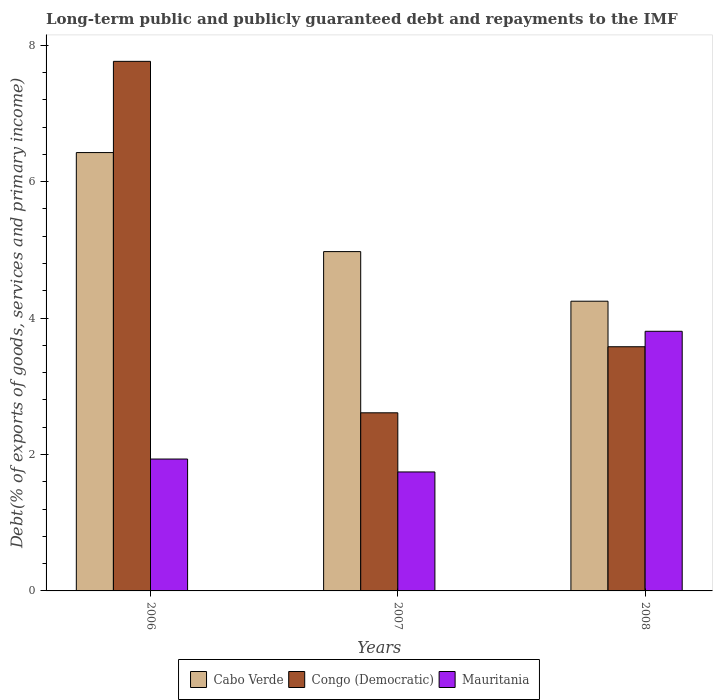How many different coloured bars are there?
Provide a short and direct response. 3. What is the debt and repayments in Congo (Democratic) in 2006?
Make the answer very short. 7.76. Across all years, what is the maximum debt and repayments in Mauritania?
Keep it short and to the point. 3.81. Across all years, what is the minimum debt and repayments in Cabo Verde?
Provide a short and direct response. 4.25. In which year was the debt and repayments in Congo (Democratic) maximum?
Provide a short and direct response. 2006. In which year was the debt and repayments in Cabo Verde minimum?
Keep it short and to the point. 2008. What is the total debt and repayments in Mauritania in the graph?
Ensure brevity in your answer.  7.48. What is the difference between the debt and repayments in Congo (Democratic) in 2006 and that in 2008?
Offer a very short reply. 4.18. What is the difference between the debt and repayments in Mauritania in 2007 and the debt and repayments in Congo (Democratic) in 2006?
Your answer should be compact. -6.02. What is the average debt and repayments in Mauritania per year?
Ensure brevity in your answer.  2.49. In the year 2007, what is the difference between the debt and repayments in Cabo Verde and debt and repayments in Mauritania?
Give a very brief answer. 3.23. What is the ratio of the debt and repayments in Mauritania in 2006 to that in 2008?
Keep it short and to the point. 0.51. Is the difference between the debt and repayments in Cabo Verde in 2006 and 2008 greater than the difference between the debt and repayments in Mauritania in 2006 and 2008?
Your answer should be very brief. Yes. What is the difference between the highest and the second highest debt and repayments in Cabo Verde?
Provide a short and direct response. 1.45. What is the difference between the highest and the lowest debt and repayments in Congo (Democratic)?
Your answer should be compact. 5.15. In how many years, is the debt and repayments in Cabo Verde greater than the average debt and repayments in Cabo Verde taken over all years?
Your response must be concise. 1. What does the 3rd bar from the left in 2006 represents?
Offer a very short reply. Mauritania. What does the 1st bar from the right in 2007 represents?
Make the answer very short. Mauritania. How many years are there in the graph?
Offer a very short reply. 3. What is the difference between two consecutive major ticks on the Y-axis?
Keep it short and to the point. 2. Does the graph contain any zero values?
Offer a very short reply. No. Where does the legend appear in the graph?
Offer a very short reply. Bottom center. How many legend labels are there?
Your answer should be compact. 3. How are the legend labels stacked?
Provide a short and direct response. Horizontal. What is the title of the graph?
Provide a short and direct response. Long-term public and publicly guaranteed debt and repayments to the IMF. What is the label or title of the X-axis?
Your answer should be compact. Years. What is the label or title of the Y-axis?
Provide a succinct answer. Debt(% of exports of goods, services and primary income). What is the Debt(% of exports of goods, services and primary income) of Cabo Verde in 2006?
Provide a short and direct response. 6.43. What is the Debt(% of exports of goods, services and primary income) in Congo (Democratic) in 2006?
Provide a succinct answer. 7.76. What is the Debt(% of exports of goods, services and primary income) of Mauritania in 2006?
Your answer should be very brief. 1.93. What is the Debt(% of exports of goods, services and primary income) of Cabo Verde in 2007?
Your answer should be compact. 4.97. What is the Debt(% of exports of goods, services and primary income) of Congo (Democratic) in 2007?
Offer a very short reply. 2.61. What is the Debt(% of exports of goods, services and primary income) of Mauritania in 2007?
Ensure brevity in your answer.  1.74. What is the Debt(% of exports of goods, services and primary income) in Cabo Verde in 2008?
Offer a terse response. 4.25. What is the Debt(% of exports of goods, services and primary income) of Congo (Democratic) in 2008?
Offer a terse response. 3.58. What is the Debt(% of exports of goods, services and primary income) of Mauritania in 2008?
Provide a short and direct response. 3.81. Across all years, what is the maximum Debt(% of exports of goods, services and primary income) in Cabo Verde?
Keep it short and to the point. 6.43. Across all years, what is the maximum Debt(% of exports of goods, services and primary income) of Congo (Democratic)?
Make the answer very short. 7.76. Across all years, what is the maximum Debt(% of exports of goods, services and primary income) of Mauritania?
Offer a very short reply. 3.81. Across all years, what is the minimum Debt(% of exports of goods, services and primary income) of Cabo Verde?
Give a very brief answer. 4.25. Across all years, what is the minimum Debt(% of exports of goods, services and primary income) of Congo (Democratic)?
Provide a short and direct response. 2.61. Across all years, what is the minimum Debt(% of exports of goods, services and primary income) of Mauritania?
Ensure brevity in your answer.  1.74. What is the total Debt(% of exports of goods, services and primary income) in Cabo Verde in the graph?
Your response must be concise. 15.65. What is the total Debt(% of exports of goods, services and primary income) in Congo (Democratic) in the graph?
Provide a succinct answer. 13.96. What is the total Debt(% of exports of goods, services and primary income) in Mauritania in the graph?
Keep it short and to the point. 7.48. What is the difference between the Debt(% of exports of goods, services and primary income) in Cabo Verde in 2006 and that in 2007?
Ensure brevity in your answer.  1.45. What is the difference between the Debt(% of exports of goods, services and primary income) in Congo (Democratic) in 2006 and that in 2007?
Your answer should be compact. 5.15. What is the difference between the Debt(% of exports of goods, services and primary income) in Mauritania in 2006 and that in 2007?
Keep it short and to the point. 0.19. What is the difference between the Debt(% of exports of goods, services and primary income) in Cabo Verde in 2006 and that in 2008?
Keep it short and to the point. 2.18. What is the difference between the Debt(% of exports of goods, services and primary income) of Congo (Democratic) in 2006 and that in 2008?
Your answer should be compact. 4.18. What is the difference between the Debt(% of exports of goods, services and primary income) in Mauritania in 2006 and that in 2008?
Give a very brief answer. -1.87. What is the difference between the Debt(% of exports of goods, services and primary income) in Cabo Verde in 2007 and that in 2008?
Provide a succinct answer. 0.73. What is the difference between the Debt(% of exports of goods, services and primary income) of Congo (Democratic) in 2007 and that in 2008?
Make the answer very short. -0.97. What is the difference between the Debt(% of exports of goods, services and primary income) in Mauritania in 2007 and that in 2008?
Your response must be concise. -2.06. What is the difference between the Debt(% of exports of goods, services and primary income) of Cabo Verde in 2006 and the Debt(% of exports of goods, services and primary income) of Congo (Democratic) in 2007?
Give a very brief answer. 3.82. What is the difference between the Debt(% of exports of goods, services and primary income) of Cabo Verde in 2006 and the Debt(% of exports of goods, services and primary income) of Mauritania in 2007?
Give a very brief answer. 4.68. What is the difference between the Debt(% of exports of goods, services and primary income) of Congo (Democratic) in 2006 and the Debt(% of exports of goods, services and primary income) of Mauritania in 2007?
Offer a very short reply. 6.02. What is the difference between the Debt(% of exports of goods, services and primary income) of Cabo Verde in 2006 and the Debt(% of exports of goods, services and primary income) of Congo (Democratic) in 2008?
Provide a succinct answer. 2.85. What is the difference between the Debt(% of exports of goods, services and primary income) in Cabo Verde in 2006 and the Debt(% of exports of goods, services and primary income) in Mauritania in 2008?
Keep it short and to the point. 2.62. What is the difference between the Debt(% of exports of goods, services and primary income) in Congo (Democratic) in 2006 and the Debt(% of exports of goods, services and primary income) in Mauritania in 2008?
Provide a succinct answer. 3.96. What is the difference between the Debt(% of exports of goods, services and primary income) of Cabo Verde in 2007 and the Debt(% of exports of goods, services and primary income) of Congo (Democratic) in 2008?
Provide a succinct answer. 1.39. What is the difference between the Debt(% of exports of goods, services and primary income) of Cabo Verde in 2007 and the Debt(% of exports of goods, services and primary income) of Mauritania in 2008?
Keep it short and to the point. 1.17. What is the difference between the Debt(% of exports of goods, services and primary income) of Congo (Democratic) in 2007 and the Debt(% of exports of goods, services and primary income) of Mauritania in 2008?
Keep it short and to the point. -1.2. What is the average Debt(% of exports of goods, services and primary income) in Cabo Verde per year?
Your response must be concise. 5.22. What is the average Debt(% of exports of goods, services and primary income) in Congo (Democratic) per year?
Offer a very short reply. 4.65. What is the average Debt(% of exports of goods, services and primary income) of Mauritania per year?
Your response must be concise. 2.49. In the year 2006, what is the difference between the Debt(% of exports of goods, services and primary income) in Cabo Verde and Debt(% of exports of goods, services and primary income) in Congo (Democratic)?
Ensure brevity in your answer.  -1.34. In the year 2006, what is the difference between the Debt(% of exports of goods, services and primary income) in Cabo Verde and Debt(% of exports of goods, services and primary income) in Mauritania?
Your answer should be compact. 4.49. In the year 2006, what is the difference between the Debt(% of exports of goods, services and primary income) in Congo (Democratic) and Debt(% of exports of goods, services and primary income) in Mauritania?
Ensure brevity in your answer.  5.83. In the year 2007, what is the difference between the Debt(% of exports of goods, services and primary income) in Cabo Verde and Debt(% of exports of goods, services and primary income) in Congo (Democratic)?
Your answer should be very brief. 2.36. In the year 2007, what is the difference between the Debt(% of exports of goods, services and primary income) of Cabo Verde and Debt(% of exports of goods, services and primary income) of Mauritania?
Ensure brevity in your answer.  3.23. In the year 2007, what is the difference between the Debt(% of exports of goods, services and primary income) of Congo (Democratic) and Debt(% of exports of goods, services and primary income) of Mauritania?
Provide a succinct answer. 0.87. In the year 2008, what is the difference between the Debt(% of exports of goods, services and primary income) of Cabo Verde and Debt(% of exports of goods, services and primary income) of Congo (Democratic)?
Your response must be concise. 0.67. In the year 2008, what is the difference between the Debt(% of exports of goods, services and primary income) in Cabo Verde and Debt(% of exports of goods, services and primary income) in Mauritania?
Offer a very short reply. 0.44. In the year 2008, what is the difference between the Debt(% of exports of goods, services and primary income) of Congo (Democratic) and Debt(% of exports of goods, services and primary income) of Mauritania?
Your response must be concise. -0.23. What is the ratio of the Debt(% of exports of goods, services and primary income) in Cabo Verde in 2006 to that in 2007?
Provide a short and direct response. 1.29. What is the ratio of the Debt(% of exports of goods, services and primary income) in Congo (Democratic) in 2006 to that in 2007?
Offer a terse response. 2.97. What is the ratio of the Debt(% of exports of goods, services and primary income) of Mauritania in 2006 to that in 2007?
Make the answer very short. 1.11. What is the ratio of the Debt(% of exports of goods, services and primary income) in Cabo Verde in 2006 to that in 2008?
Offer a very short reply. 1.51. What is the ratio of the Debt(% of exports of goods, services and primary income) of Congo (Democratic) in 2006 to that in 2008?
Make the answer very short. 2.17. What is the ratio of the Debt(% of exports of goods, services and primary income) of Mauritania in 2006 to that in 2008?
Your response must be concise. 0.51. What is the ratio of the Debt(% of exports of goods, services and primary income) of Cabo Verde in 2007 to that in 2008?
Your response must be concise. 1.17. What is the ratio of the Debt(% of exports of goods, services and primary income) of Congo (Democratic) in 2007 to that in 2008?
Your response must be concise. 0.73. What is the ratio of the Debt(% of exports of goods, services and primary income) of Mauritania in 2007 to that in 2008?
Ensure brevity in your answer.  0.46. What is the difference between the highest and the second highest Debt(% of exports of goods, services and primary income) of Cabo Verde?
Provide a succinct answer. 1.45. What is the difference between the highest and the second highest Debt(% of exports of goods, services and primary income) of Congo (Democratic)?
Your answer should be compact. 4.18. What is the difference between the highest and the second highest Debt(% of exports of goods, services and primary income) of Mauritania?
Give a very brief answer. 1.87. What is the difference between the highest and the lowest Debt(% of exports of goods, services and primary income) in Cabo Verde?
Keep it short and to the point. 2.18. What is the difference between the highest and the lowest Debt(% of exports of goods, services and primary income) in Congo (Democratic)?
Provide a short and direct response. 5.15. What is the difference between the highest and the lowest Debt(% of exports of goods, services and primary income) in Mauritania?
Your response must be concise. 2.06. 